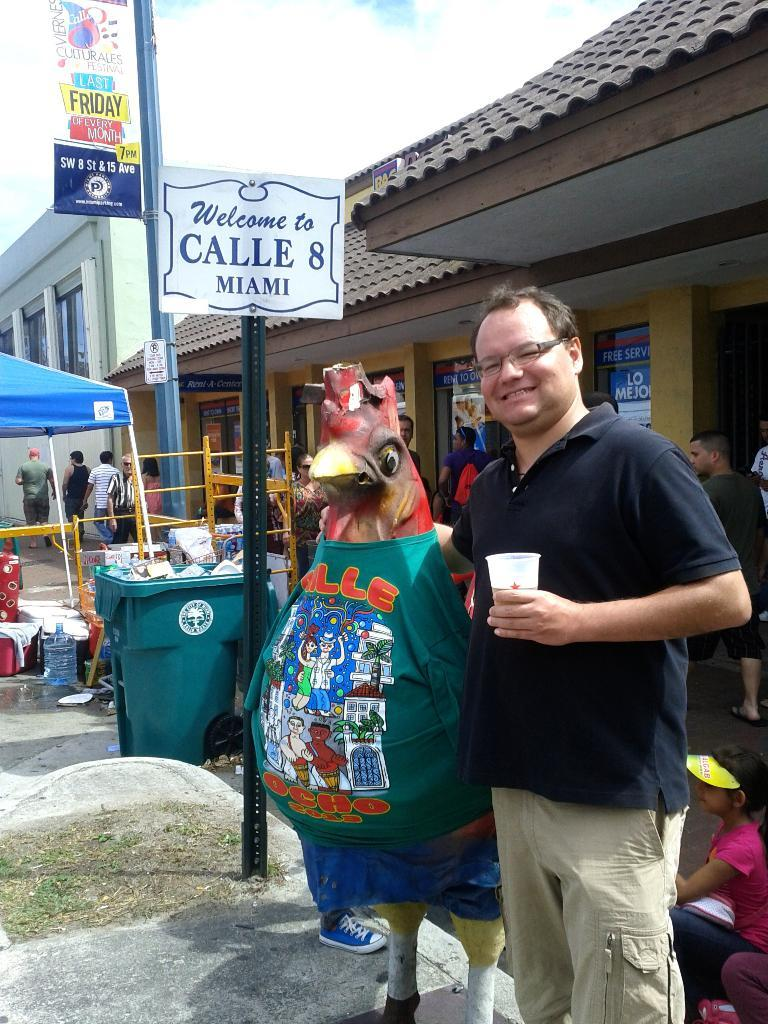<image>
Summarize the visual content of the image. A man and statue of a chicken standing next to a sign that says Welcome to Calle 8 Miami. 